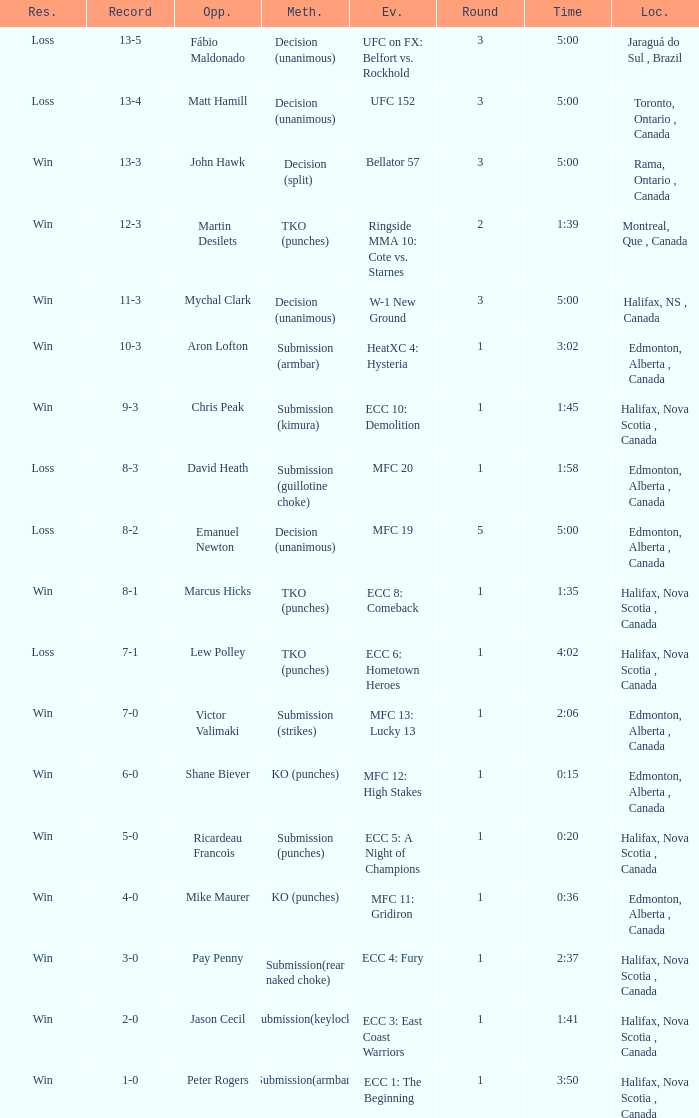What is the location of the match with an event of ecc 8: comeback? Halifax, Nova Scotia , Canada. 